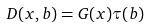Convert formula to latex. <formula><loc_0><loc_0><loc_500><loc_500>D ( x , { b } ) = G ( x ) \tau ( { b } )</formula> 